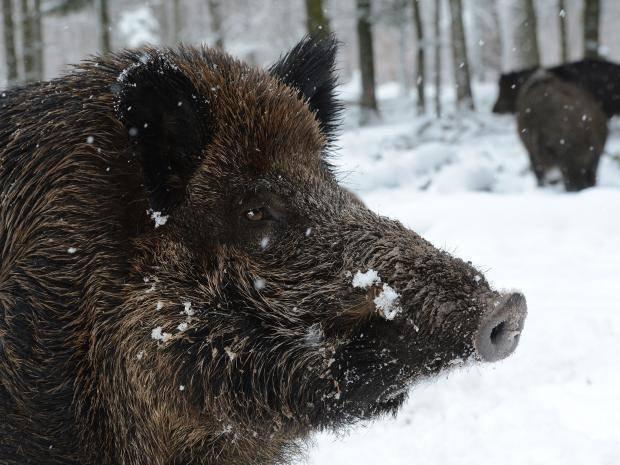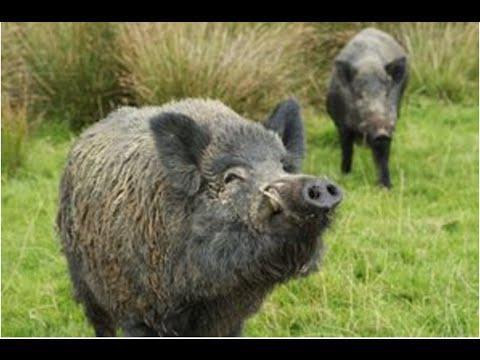The first image is the image on the left, the second image is the image on the right. For the images shown, is this caption "In one image, a boar is standing in snow." true? Answer yes or no. Yes. The first image is the image on the left, the second image is the image on the right. For the images shown, is this caption "One image contains only baby piglets with distinctive brown and beige striped fur, standing on ground with bright green grass." true? Answer yes or no. No. 